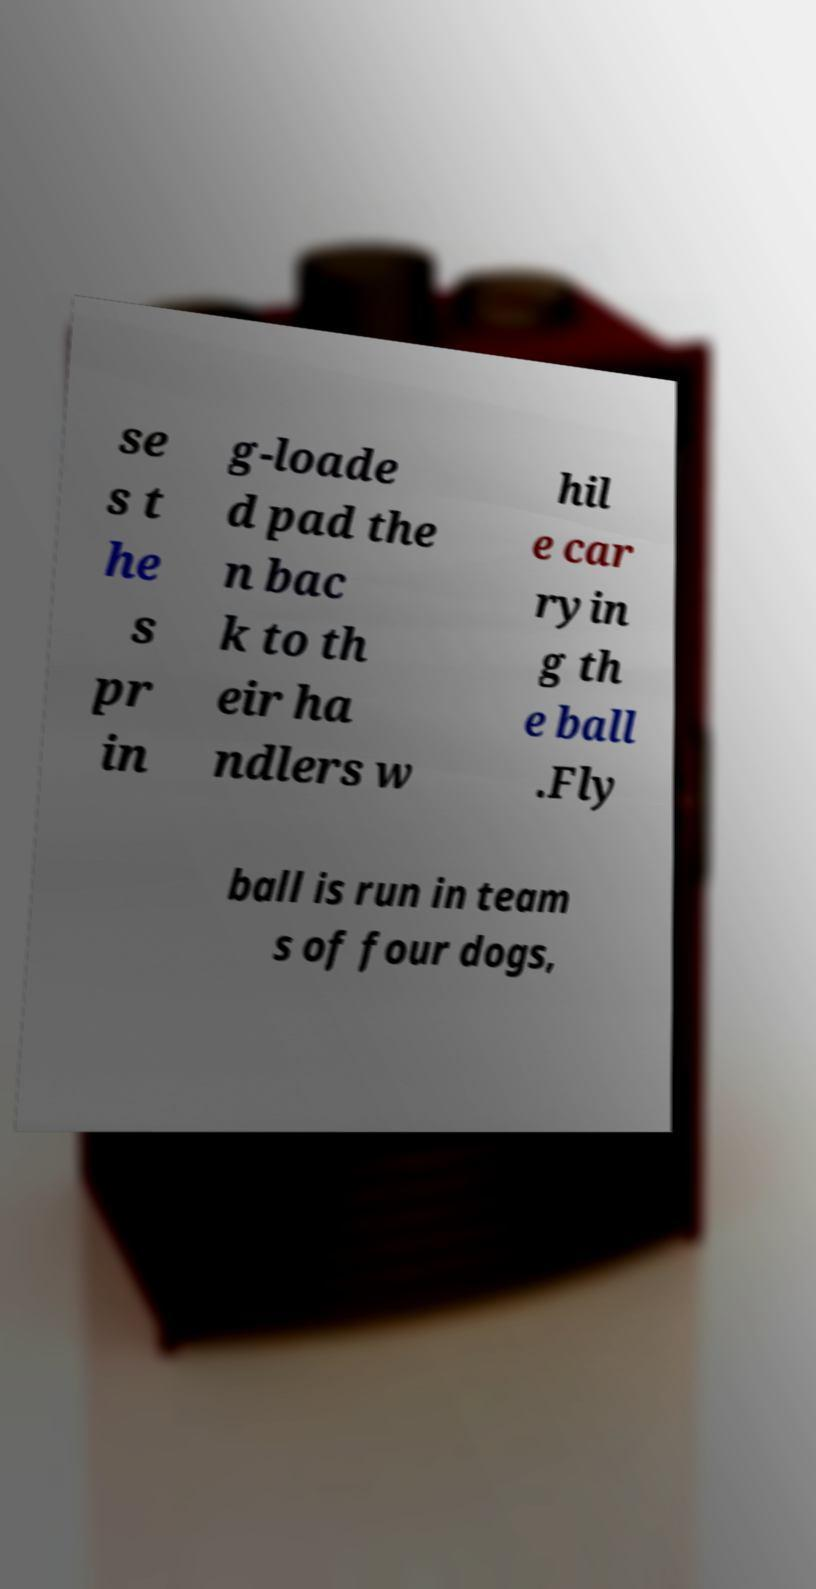I need the written content from this picture converted into text. Can you do that? se s t he s pr in g-loade d pad the n bac k to th eir ha ndlers w hil e car ryin g th e ball .Fly ball is run in team s of four dogs, 